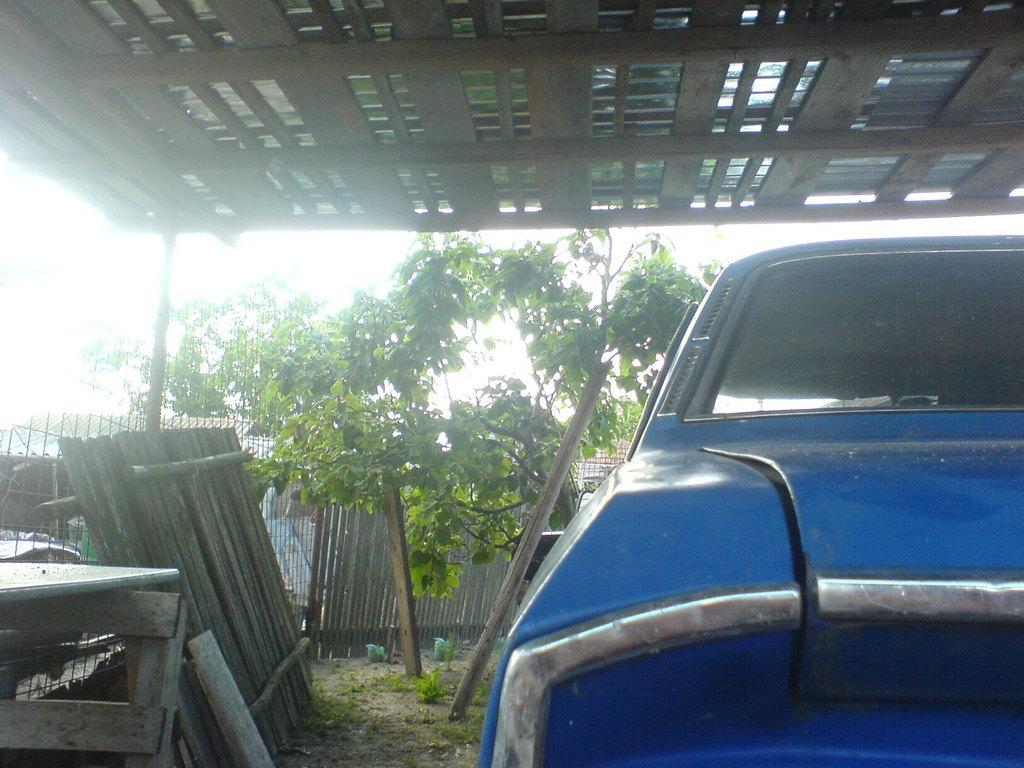Describe this image in one or two sentences. In the picture we can see a part of the car which is blue in color placed under the shed and beside it, we can see railing and in the background, we can see some trees and behind it we can see a part of the sky. 